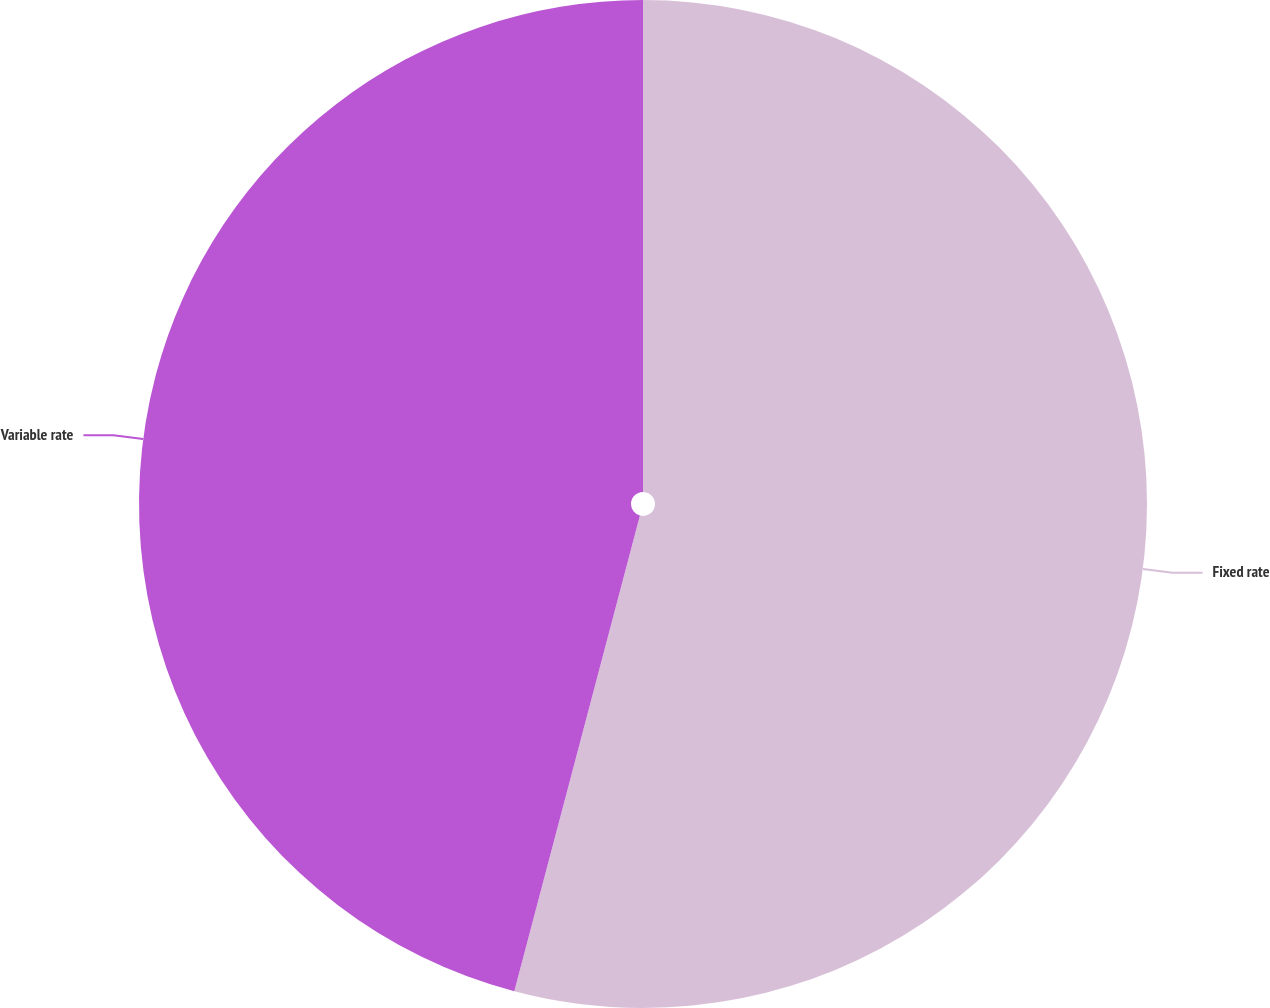Convert chart. <chart><loc_0><loc_0><loc_500><loc_500><pie_chart><fcel>Fixed rate<fcel>Variable rate<nl><fcel>54.11%<fcel>45.89%<nl></chart> 